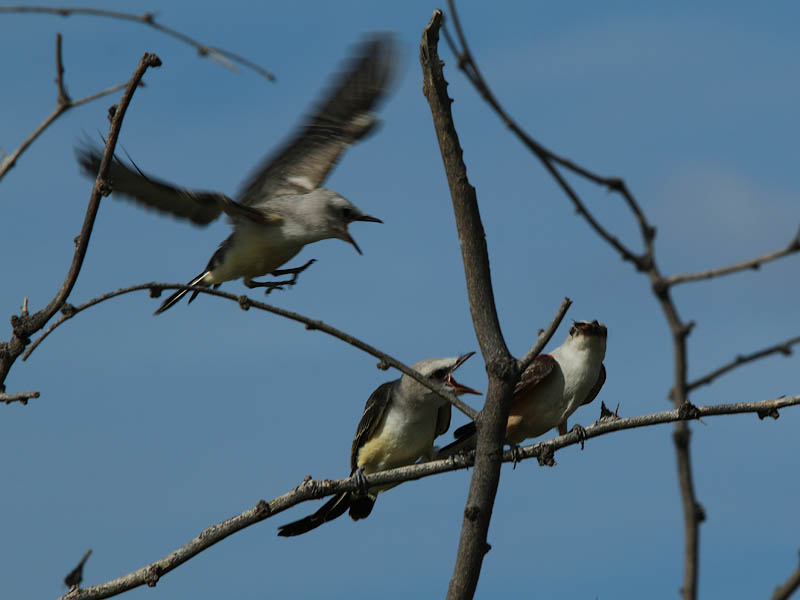Considering the open beak of the front perched bird and the presence of the other birds, what might be the reason for this behavior and how does it relate to the actions of the other two birds? The open beak of the front bird, oriented skyward, is a posture that is commonly associated with feeding behavior, especially in young birds waiting to be fed by a parent. This suggests that the bird could be either calling for food or anticipating the approach of a parent with food. The bird in flight, due to the blurriness and proximity to the perched birds, could be interpreted as either arriving with food or being another young bird in the process of learning to fly. The third bird, being perched and facing the same direction as the bird with an open beak, could be waiting its turn for feeding or is simply observing. Based on the image alone, it seems likely that this is a scene of parental care or sibling interaction among the birds. 